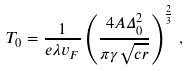Convert formula to latex. <formula><loc_0><loc_0><loc_500><loc_500>T _ { 0 } = \frac { 1 } { e \lambda v _ { F } } \left ( \frac { 4 A \Delta _ { 0 } ^ { 2 } } { \pi \gamma \sqrt { c r } } \right ) ^ { \frac { 2 } { 3 } } \, ,</formula> 